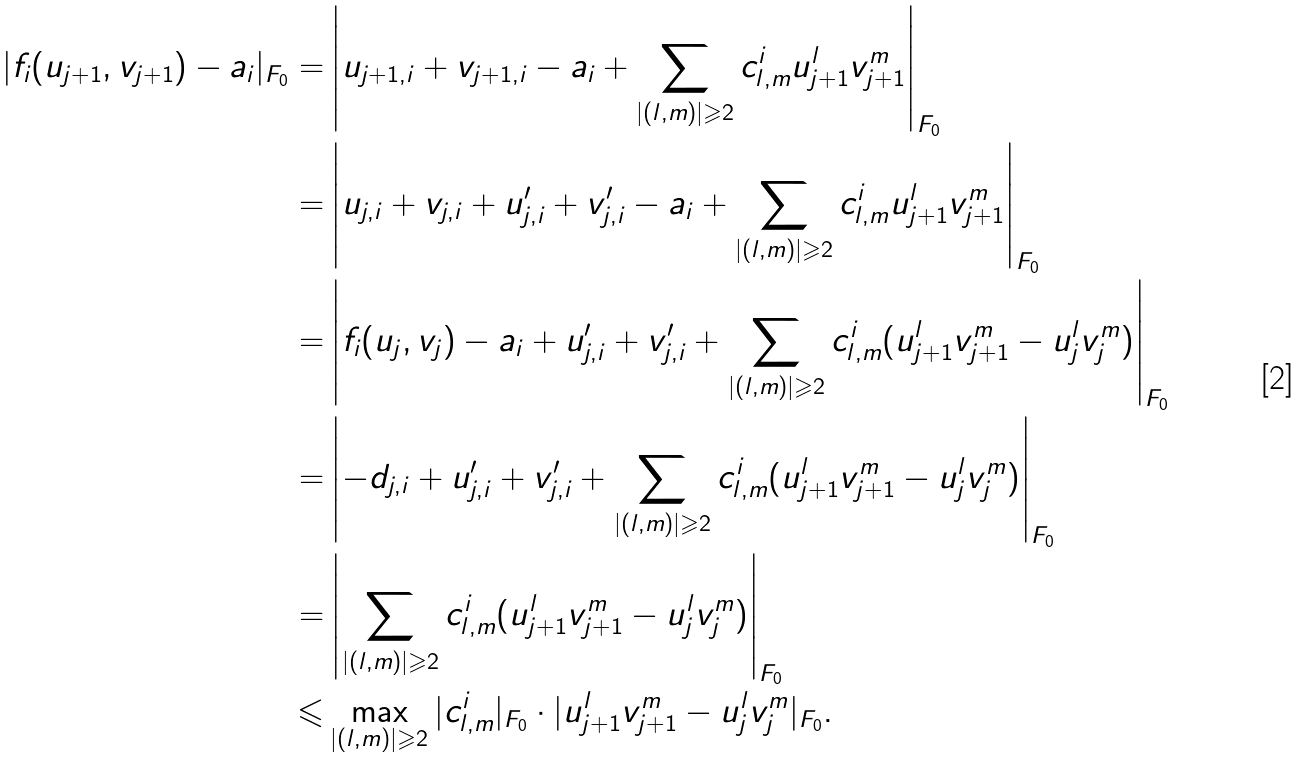Convert formula to latex. <formula><loc_0><loc_0><loc_500><loc_500>| f _ { i } ( u _ { j + 1 } , v _ { j + 1 } ) - a _ { i } | _ { F _ { 0 } } = & \left | u _ { j + 1 , i } + v _ { j + 1 , i } - a _ { i } + \sum _ { | ( l , m ) | \geqslant 2 } c _ { l , m } ^ { i } u _ { j + 1 } ^ { l } v _ { j + 1 } ^ { m } \right | _ { F _ { 0 } } \\ = & \left | u _ { j , i } + v _ { j , i } + u ^ { \prime } _ { j , i } + v ^ { \prime } _ { j , i } - a _ { i } + \sum _ { | ( l , m ) | \geqslant 2 } c _ { l , m } ^ { i } u _ { j + 1 } ^ { l } v _ { j + 1 } ^ { m } \right | _ { F _ { 0 } } \\ = & \left | f _ { i } ( u _ { j } , v _ { j } ) - a _ { i } + u ^ { \prime } _ { j , i } + v ^ { \prime } _ { j , i } + \sum _ { | ( l , m ) | \geqslant 2 } c _ { l , m } ^ { i } ( u _ { j + 1 } ^ { l } v _ { j + 1 } ^ { m } - u _ { j } ^ { l } v _ { j } ^ { m } ) \right | _ { F _ { 0 } } \\ = & \left | - d _ { j , i } + u ^ { \prime } _ { j , i } + v ^ { \prime } _ { j , i } + \sum _ { | ( l , m ) | \geqslant 2 } c _ { l , m } ^ { i } ( u _ { j + 1 } ^ { l } v _ { j + 1 } ^ { m } - u _ { j } ^ { l } v _ { j } ^ { m } ) \right | _ { F _ { 0 } } \\ = & \left | \sum _ { | ( l , m ) | \geqslant 2 } c _ { l , m } ^ { i } ( u _ { j + 1 } ^ { l } v _ { j + 1 } ^ { m } - u _ { j } ^ { l } v _ { j } ^ { m } ) \right | _ { F _ { 0 } } \\ \leqslant & \max _ { | ( l , m ) | \geqslant 2 } | c _ { l , m } ^ { i } | _ { F _ { 0 } } \cdot | u _ { j + 1 } ^ { l } v _ { j + 1 } ^ { m } - u _ { j } ^ { l } v _ { j } ^ { m } | _ { F _ { 0 } } . \\</formula> 